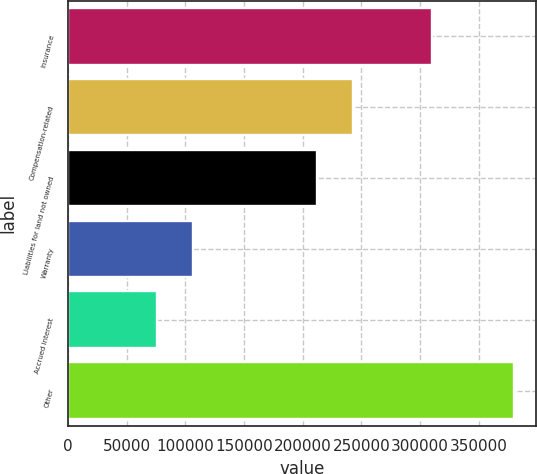Convert chart. <chart><loc_0><loc_0><loc_500><loc_500><bar_chart><fcel>Insurance<fcel>Compensation-related<fcel>Liabilities for land not owned<fcel>Warranty<fcel>Accrued interest<fcel>Other<nl><fcel>309874<fcel>242656<fcel>212235<fcel>106203<fcel>75782<fcel>379990<nl></chart> 